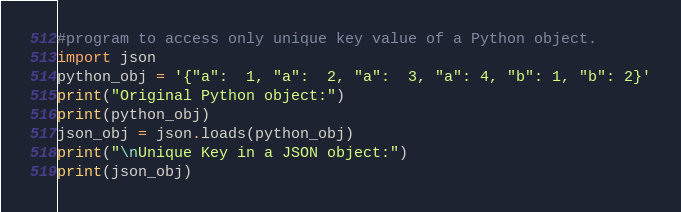<code> <loc_0><loc_0><loc_500><loc_500><_Python_>#program to access only unique key value of a Python object.
import json
python_obj = '{"a":  1, "a":  2, "a":  3, "a": 4, "b": 1, "b": 2}'
print("Original Python object:")
print(python_obj)
json_obj = json.loads(python_obj)
print("\nUnique Key in a JSON object:")
print(json_obj) </code> 